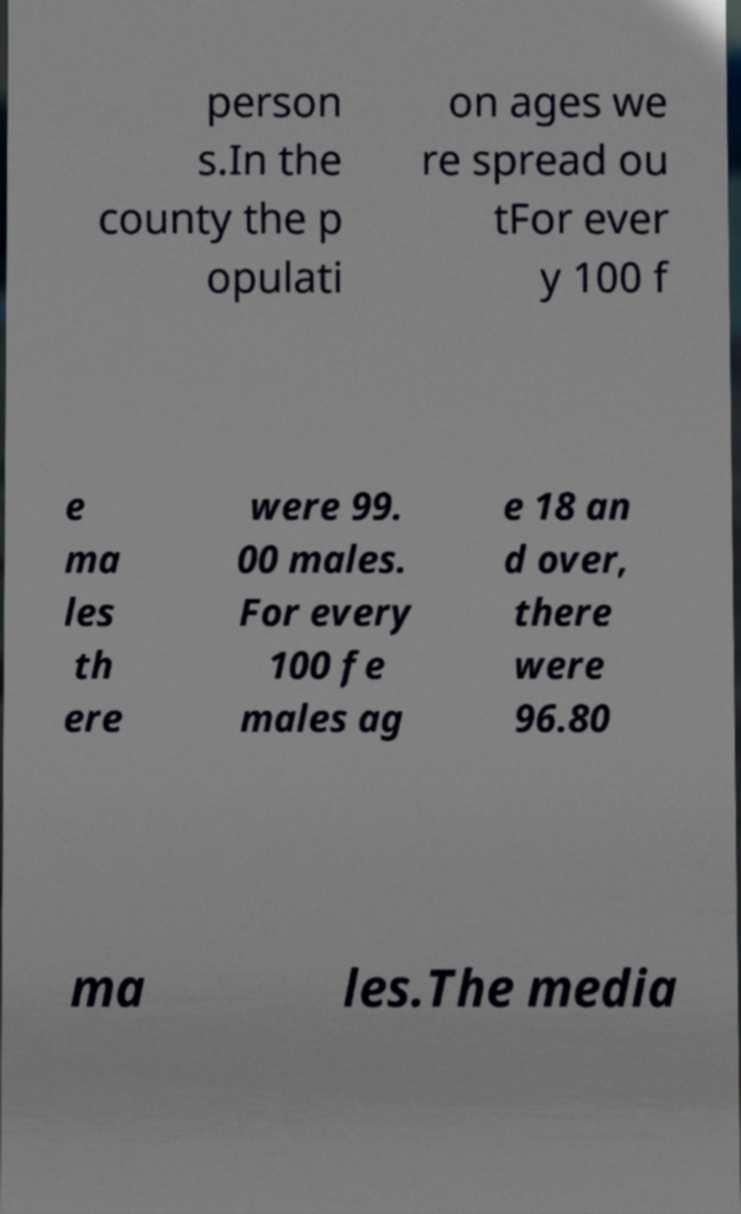Could you extract and type out the text from this image? person s.In the county the p opulati on ages we re spread ou tFor ever y 100 f e ma les th ere were 99. 00 males. For every 100 fe males ag e 18 an d over, there were 96.80 ma les.The media 